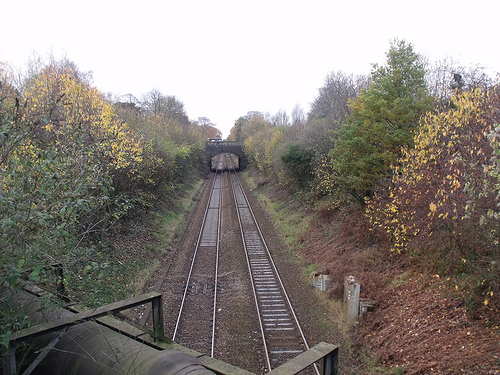<image>
Is there a train track under the bridge? Yes. The train track is positioned underneath the bridge, with the bridge above it in the vertical space. 